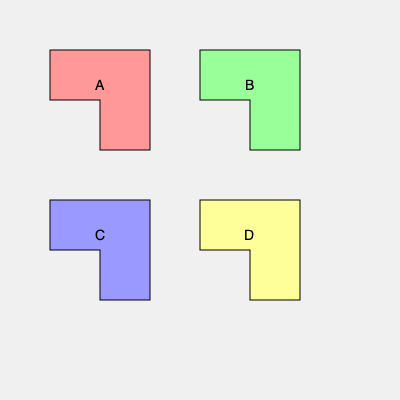In a healthcare facility optimization project, you are tasked with arranging four irregularly shaped departments (A, B, C, and D) to maximize efficiency. Which two departments, when combined, would form a perfect square? To solve this spatial intelligence question, we need to analyze the shapes of the four departments and visualize how they might fit together:

1. Observe that all four departments have the same basic L-shape, but with different orientations.

2. Department A is oriented with the shorter leg pointing right and the longer leg pointing down.

3. Department B is a mirror image of A, with the shorter leg pointing left and the longer leg pointing down.

4. Department C is similar to A, but rotated 90 degrees clockwise, with the shorter leg pointing up and the longer leg pointing right.

5. Department D is similar to B, but rotated 90 degrees clockwise, with the shorter leg pointing up and the longer leg pointing left.

6. To form a perfect square, we need two departments that can fit together without gaps or overlaps.

7. Analyzing the orientations, we can see that departments A and B, when placed next to each other, would form a perfect square. The shorter leg of A would fill the gap in B, and vice versa.

8. Similarly, departments C and D would also form a perfect square when combined, as they are the rotated versions of A and B.

Therefore, either the combination of A and B or the combination of C and D would form a perfect square.
Answer: A and B, or C and D 